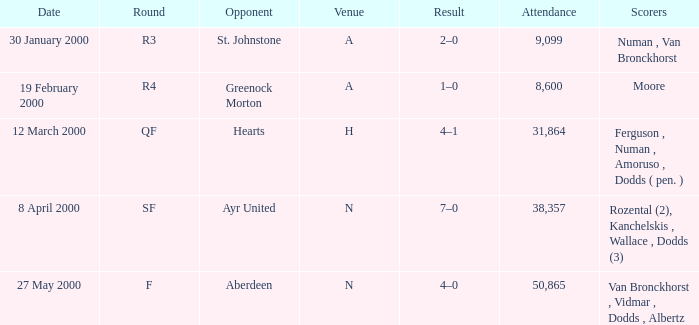Which site was on 27 may 2000? N. 